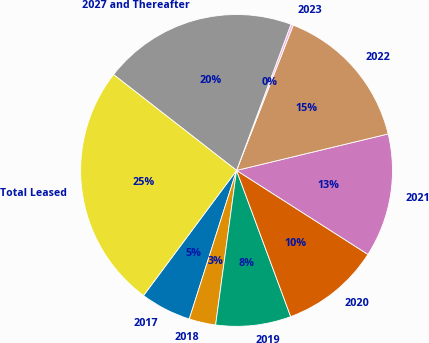Convert chart. <chart><loc_0><loc_0><loc_500><loc_500><pie_chart><fcel>2017<fcel>2018<fcel>2019<fcel>2020<fcel>2021<fcel>2022<fcel>2023<fcel>2027 and Thereafter<fcel>Total Leased<nl><fcel>5.27%<fcel>2.76%<fcel>7.79%<fcel>10.3%<fcel>12.81%<fcel>15.32%<fcel>0.25%<fcel>20.14%<fcel>25.36%<nl></chart> 